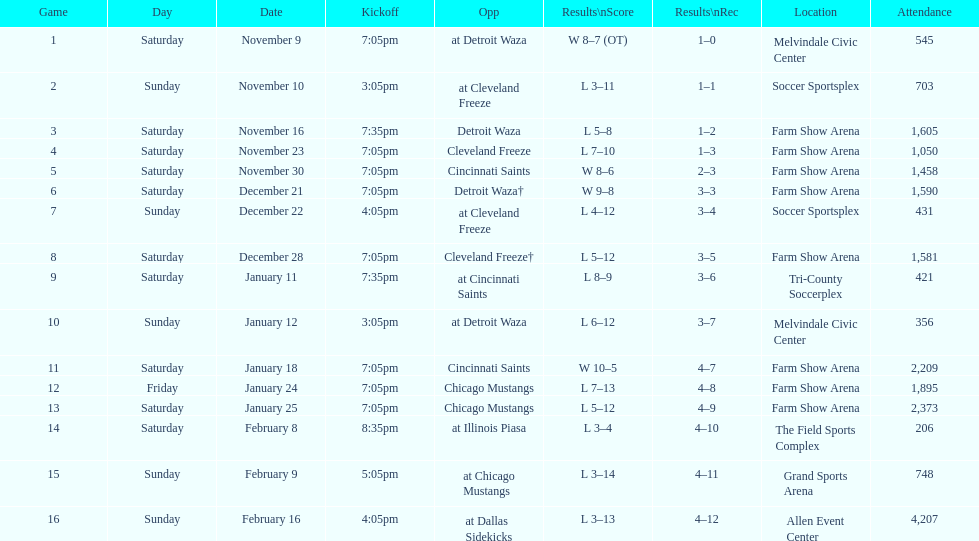Which opponent is listed first in the table? Detroit Waza. 